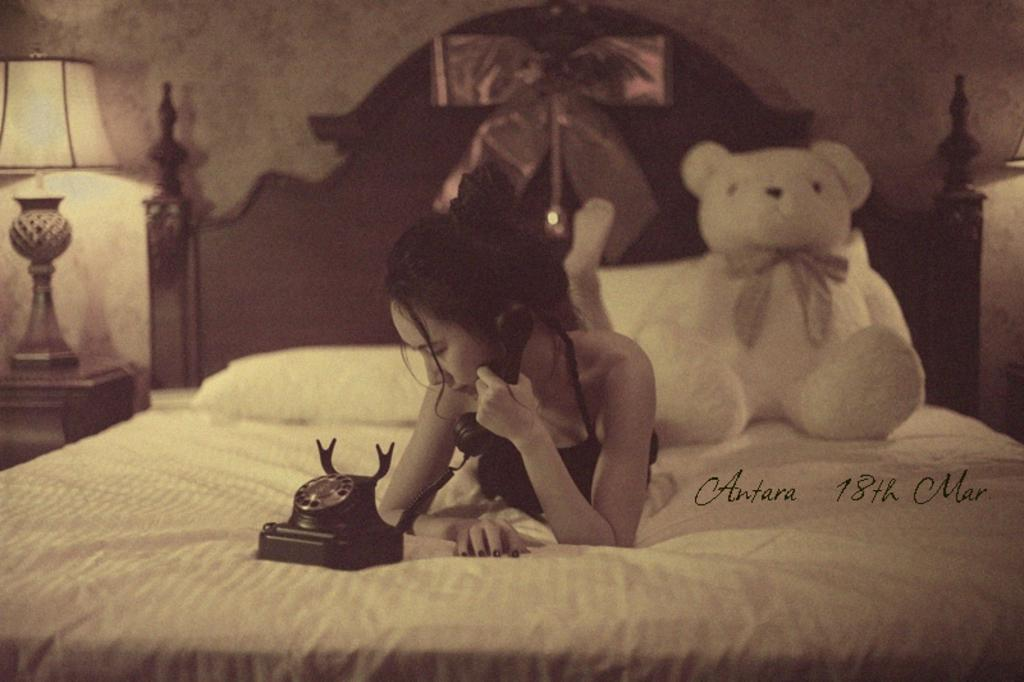What is the main piece of furniture in the image? There is a bed in the image. What items can be found on the bed? The bed contains a teddy bear and a telephone. Who is present in the image? There is a person on the bed. What is the source of light in the image? There is a lamp in front of a wall. What is the person wearing in the image? The person is wearing clothes. What type of sand can be seen on the floor in the image? There is no sand present on the floor in the image. Is there a shop visible in the image? There is no shop present in the image. 